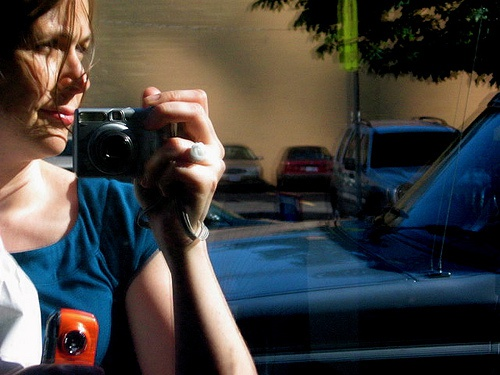Describe the objects in this image and their specific colors. I can see people in black, white, maroon, and tan tones, car in black, navy, and blue tones, car in black, navy, gray, and blue tones, cell phone in black, brown, red, and maroon tones, and car in black, maroon, and gray tones in this image. 